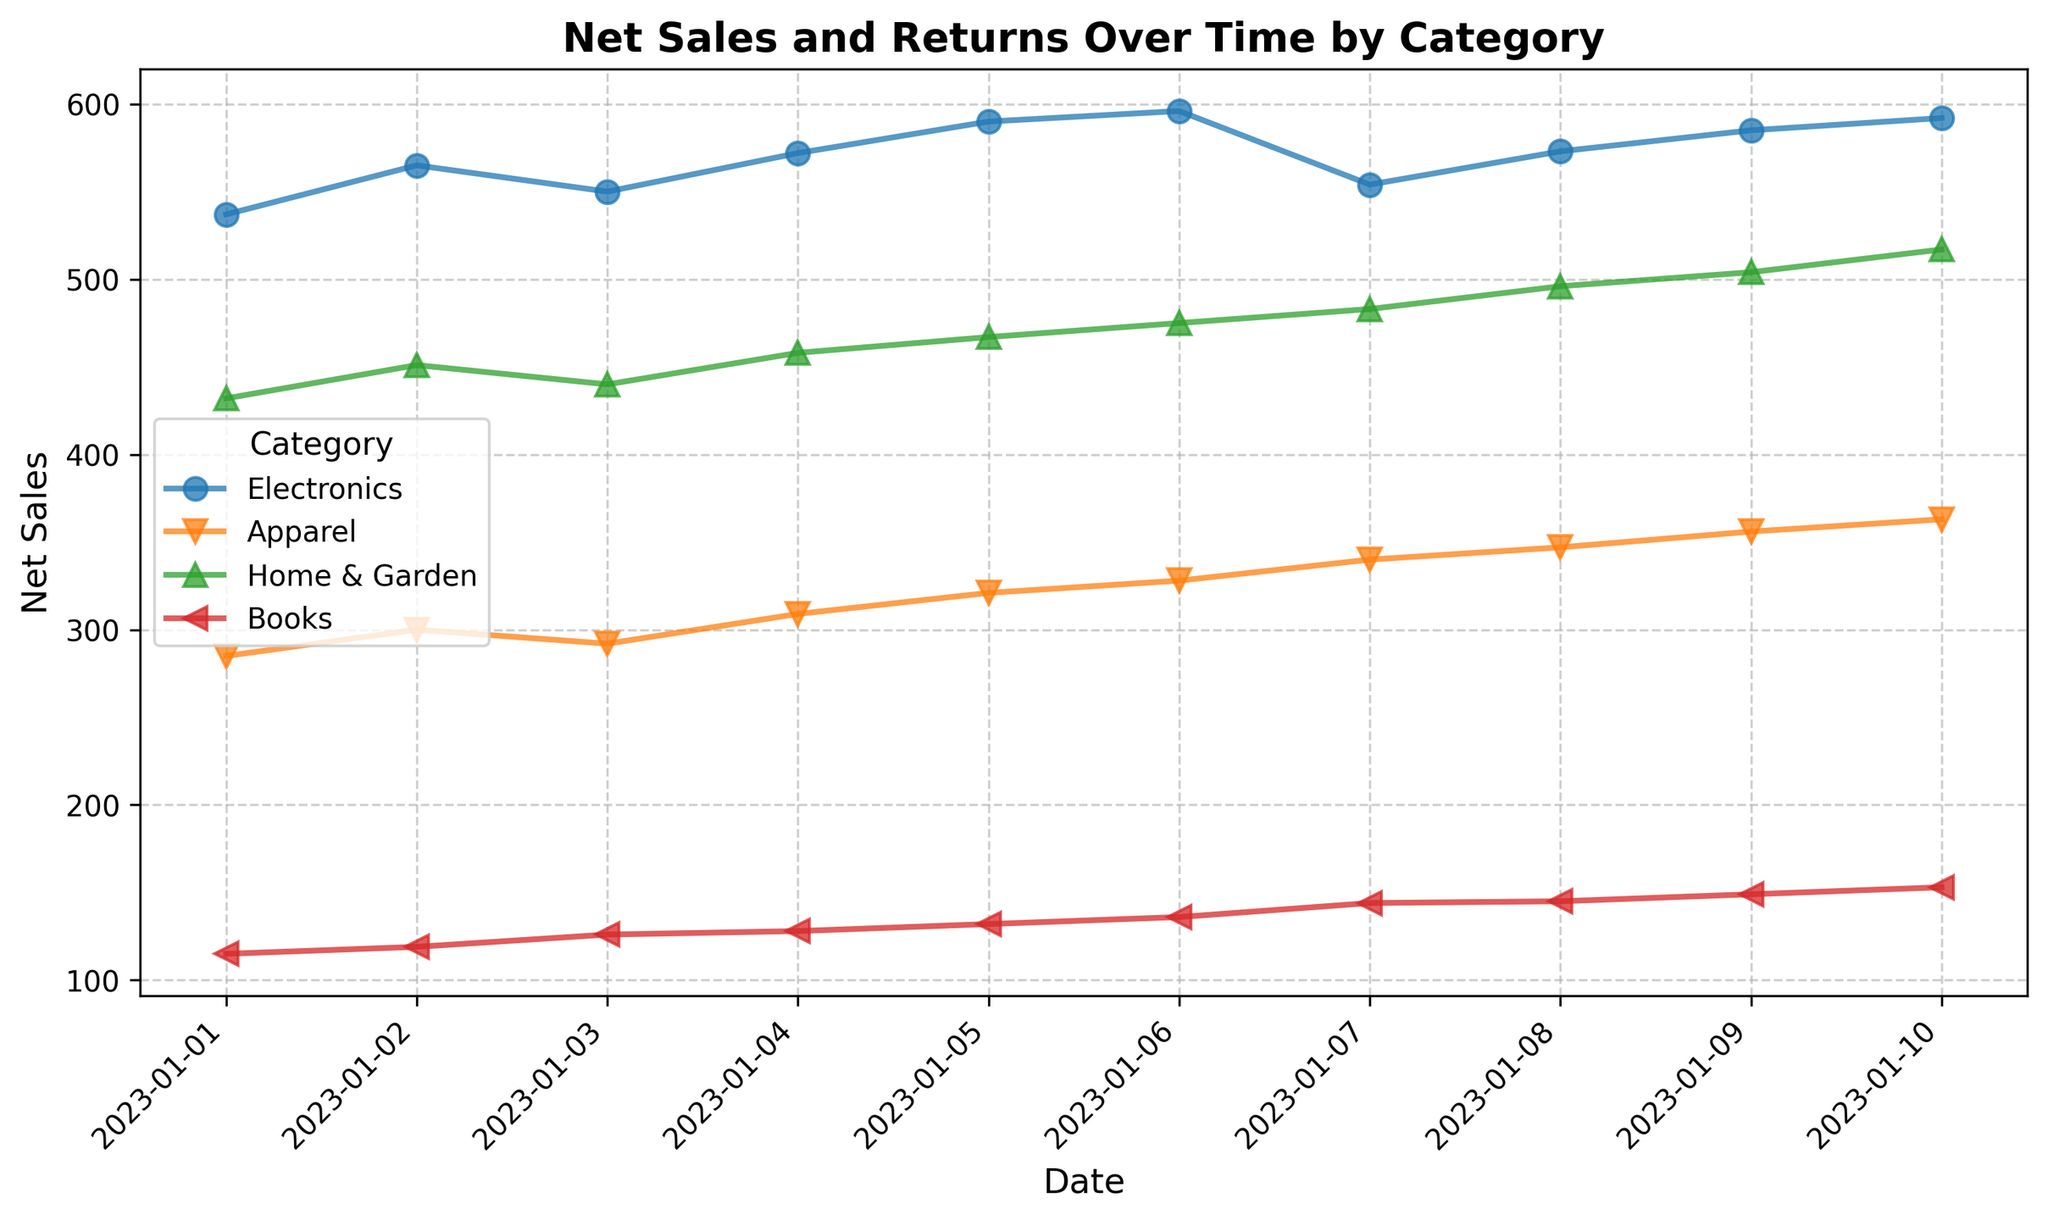Which product category had the highest net sales on the last date in the dataset? Look at the net sales values for January 10, 2023. Compare the net sales across all categories. Electronics has the highest net sales of 592.
Answer: Electronics Which day had the lowest net sales for the Home & Garden category? Check the net sales for Home & Garden on each date. The day with the lowest net sales is January 1, 2023, with 432 net sales.
Answer: January 1, 2023 What is the difference in net sales between Electronics and Apparel on January 5, 2023? Subtract the net sales of Apparel from the net sales of Electronics on January 5, 2023. The calculation is 590 (Electronics) - 321 (Apparel) = 269.
Answer: 269 On which day did Books have the highest net sales? Review the net sales for Books on each day. The highest net sales for Books is on January 10, 2023, which is 153.
Answer: January 10, 2023 Which category showed the most fluctuation in net sales over the given period? Observe the net sales trends for each category. The category with the largest up and down variations in the net sales lines over the period is Electronics.
Answer: Electronics How many days did Apparel have net sales greater than 300? Count the number of days when Apparel's net sales were more than 300. January 4, January 5, January 6, January 7, January 8, January 9, and January 10 meet the criteria, totaling 7 days.
Answer: 7 What is the average net sales for Books over the given period? Sum the net sales for Books over all the days, then divide by the number of days. The total is 1356, and there are 10 days, so the average is 135.6.
Answer: 135.6 Which date has the highest sum of net sales across all categories? Add the net sales across all categories for each date and find the largest sum. The highest sum is on January 10, 2023, which is 1647.
Answer: January 10, 2023 